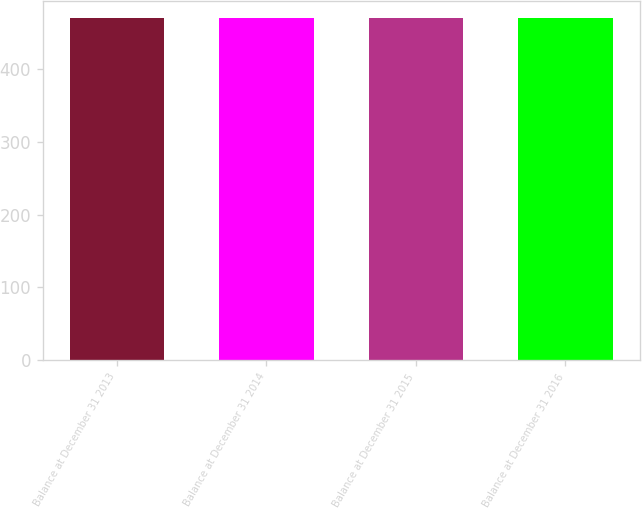<chart> <loc_0><loc_0><loc_500><loc_500><bar_chart><fcel>Balance at December 31 2013<fcel>Balance at December 31 2014<fcel>Balance at December 31 2015<fcel>Balance at December 31 2016<nl><fcel>470<fcel>470.1<fcel>470.2<fcel>470.3<nl></chart> 